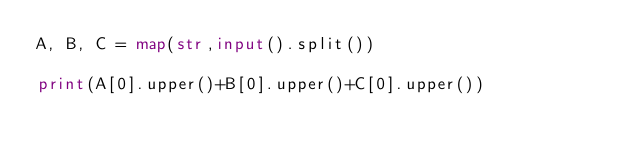<code> <loc_0><loc_0><loc_500><loc_500><_Python_>A, B, C = map(str,input().split())

print(A[0].upper()+B[0].upper()+C[0].upper())</code> 